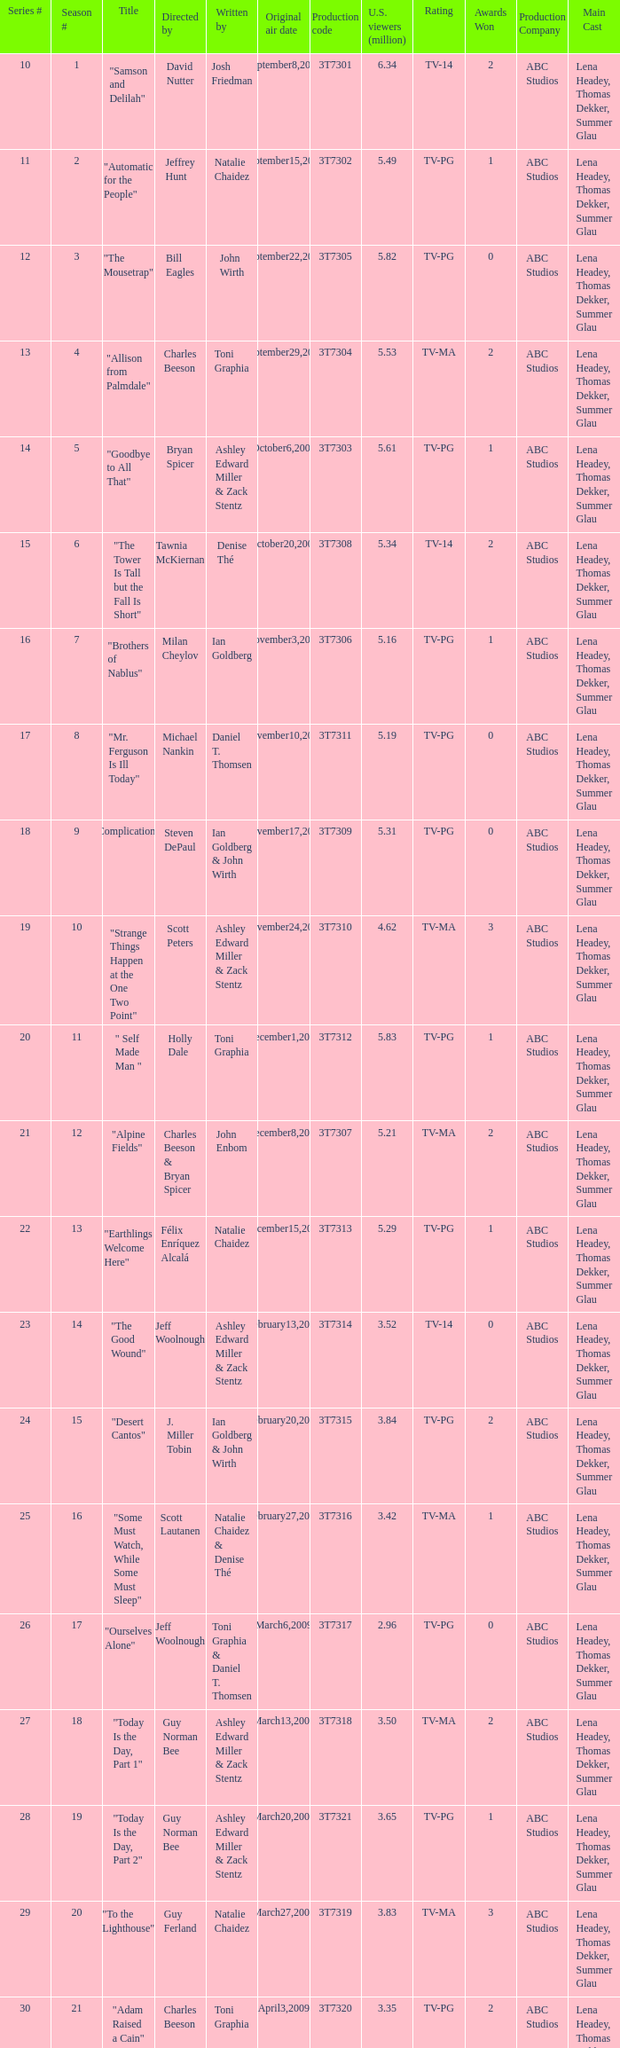Could you parse the entire table as a dict? {'header': ['Series #', 'Season #', 'Title', 'Directed by', 'Written by', 'Original air date', 'Production code', 'U.S. viewers (million)', 'Rating', 'Awards Won', 'Production Company', 'Main Cast '], 'rows': [['10', '1', '"Samson and Delilah"', 'David Nutter', 'Josh Friedman', 'September8,2008', '3T7301', '6.34', 'TV-14', '2', 'ABC Studios', 'Lena Headey, Thomas Dekker, Summer Glau'], ['11', '2', '"Automatic for the People"', 'Jeffrey Hunt', 'Natalie Chaidez', 'September15,2008', '3T7302', '5.49', 'TV-PG', '1', 'ABC Studios', 'Lena Headey, Thomas Dekker, Summer Glau'], ['12', '3', '"The Mousetrap"', 'Bill Eagles', 'John Wirth', 'September22,2008', '3T7305', '5.82', 'TV-PG', '0', 'ABC Studios', 'Lena Headey, Thomas Dekker, Summer Glau'], ['13', '4', '"Allison from Palmdale"', 'Charles Beeson', 'Toni Graphia', 'September29,2008', '3T7304', '5.53', 'TV-MA', '2', 'ABC Studios', 'Lena Headey, Thomas Dekker, Summer Glau'], ['14', '5', '"Goodbye to All That"', 'Bryan Spicer', 'Ashley Edward Miller & Zack Stentz', 'October6,2008', '3T7303', '5.61', 'TV-PG', '1', 'ABC Studios', 'Lena Headey, Thomas Dekker, Summer Glau'], ['15', '6', '"The Tower Is Tall but the Fall Is Short"', 'Tawnia McKiernan', 'Denise Thé', 'October20,2008', '3T7308', '5.34', 'TV-14', '2', 'ABC Studios', 'Lena Headey, Thomas Dekker, Summer Glau'], ['16', '7', '"Brothers of Nablus"', 'Milan Cheylov', 'Ian Goldberg', 'November3,2008', '3T7306', '5.16', 'TV-PG', '1', 'ABC Studios', 'Lena Headey, Thomas Dekker, Summer Glau'], ['17', '8', '"Mr. Ferguson Is Ill Today"', 'Michael Nankin', 'Daniel T. Thomsen', 'November10,2008', '3T7311', '5.19', 'TV-PG', '0', 'ABC Studios', 'Lena Headey, Thomas Dekker, Summer Glau'], ['18', '9', '"Complications"', 'Steven DePaul', 'Ian Goldberg & John Wirth', 'November17,2008', '3T7309', '5.31', 'TV-PG', '0', 'ABC Studios', 'Lena Headey, Thomas Dekker, Summer Glau'], ['19', '10', '"Strange Things Happen at the One Two Point"', 'Scott Peters', 'Ashley Edward Miller & Zack Stentz', 'November24,2008', '3T7310', '4.62', 'TV-MA', '3', 'ABC Studios', 'Lena Headey, Thomas Dekker, Summer Glau'], ['20', '11', '" Self Made Man "', 'Holly Dale', 'Toni Graphia', 'December1,2008', '3T7312', '5.83', 'TV-PG', '1', 'ABC Studios', 'Lena Headey, Thomas Dekker, Summer Glau'], ['21', '12', '"Alpine Fields"', 'Charles Beeson & Bryan Spicer', 'John Enbom', 'December8,2008', '3T7307', '5.21', 'TV-MA', '2', 'ABC Studios', 'Lena Headey, Thomas Dekker, Summer Glau'], ['22', '13', '"Earthlings Welcome Here"', 'Félix Enríquez Alcalá', 'Natalie Chaidez', 'December15,2008', '3T7313', '5.29', 'TV-PG', '1', 'ABC Studios', 'Lena Headey, Thomas Dekker, Summer Glau'], ['23', '14', '"The Good Wound"', 'Jeff Woolnough', 'Ashley Edward Miller & Zack Stentz', 'February13,2009', '3T7314', '3.52', 'TV-14', '0', 'ABC Studios', 'Lena Headey, Thomas Dekker, Summer Glau'], ['24', '15', '"Desert Cantos"', 'J. Miller Tobin', 'Ian Goldberg & John Wirth', 'February20,2009', '3T7315', '3.84', 'TV-PG', '2', 'ABC Studios', 'Lena Headey, Thomas Dekker, Summer Glau'], ['25', '16', '"Some Must Watch, While Some Must Sleep"', 'Scott Lautanen', 'Natalie Chaidez & Denise Thé', 'February27,2009', '3T7316', '3.42', 'TV-MA', '1', 'ABC Studios', 'Lena Headey, Thomas Dekker, Summer Glau'], ['26', '17', '"Ourselves Alone"', 'Jeff Woolnough', 'Toni Graphia & Daniel T. Thomsen', 'March6,2009', '3T7317', '2.96', 'TV-PG', '0', 'ABC Studios', 'Lena Headey, Thomas Dekker, Summer Glau'], ['27', '18', '"Today Is the Day, Part 1"', 'Guy Norman Bee', 'Ashley Edward Miller & Zack Stentz', 'March13,2009', '3T7318', '3.50', 'TV-MA', '2', 'ABC Studios', 'Lena Headey, Thomas Dekker, Summer Glau'], ['28', '19', '"Today Is the Day, Part 2"', 'Guy Norman Bee', 'Ashley Edward Miller & Zack Stentz', 'March20,2009', '3T7321', '3.65', 'TV-PG', '1', 'ABC Studios', 'Lena Headey, Thomas Dekker, Summer Glau'], ['29', '20', '"To the Lighthouse"', 'Guy Ferland', 'Natalie Chaidez', 'March27,2009', '3T7319', '3.83', 'TV-MA', '3', 'ABC Studios', 'Lena Headey, Thomas Dekker, Summer Glau'], ['30', '21', '"Adam Raised a Cain"', 'Charles Beeson', 'Toni Graphia', 'April3,2009', '3T7320', '3.35', 'TV-PG', '2', 'ABC Studios', 'Lena Headey, Thomas Dekker, Summer Glau']]} Which episode number drew in 3.84 million viewers in the U.S.? 24.0. 